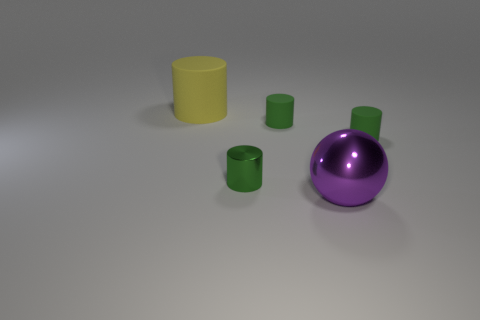Could you estimate the size of these objects relative to each other? Sure, the yellow cylinder appears to be the largest object while the cyan cubes and other cylinders seem to be smaller and similar in size to each other. 